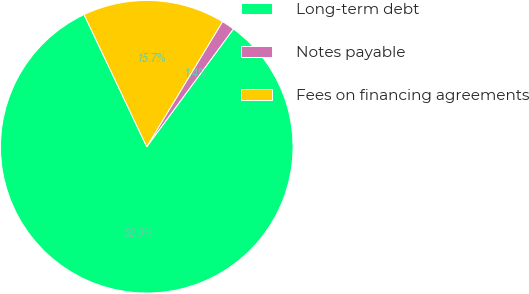Convert chart to OTSL. <chart><loc_0><loc_0><loc_500><loc_500><pie_chart><fcel>Long-term debt<fcel>Notes payable<fcel>Fees on financing agreements<nl><fcel>82.86%<fcel>1.43%<fcel>15.71%<nl></chart> 